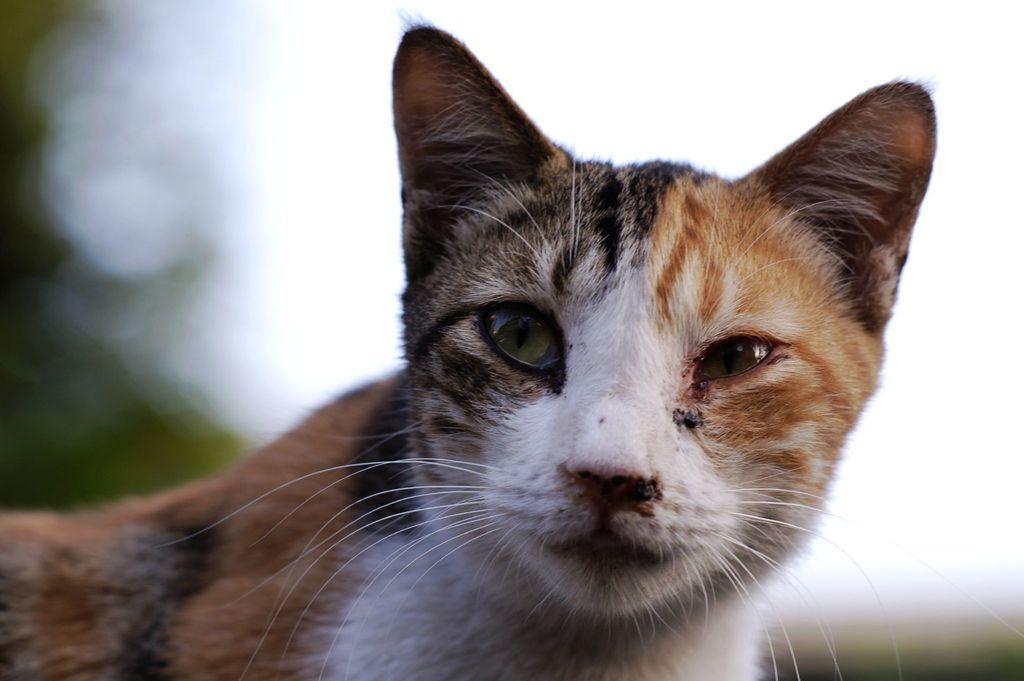Could you give a brief overview of what you see in this image? In this image I can see a cat. The background is blurred. 